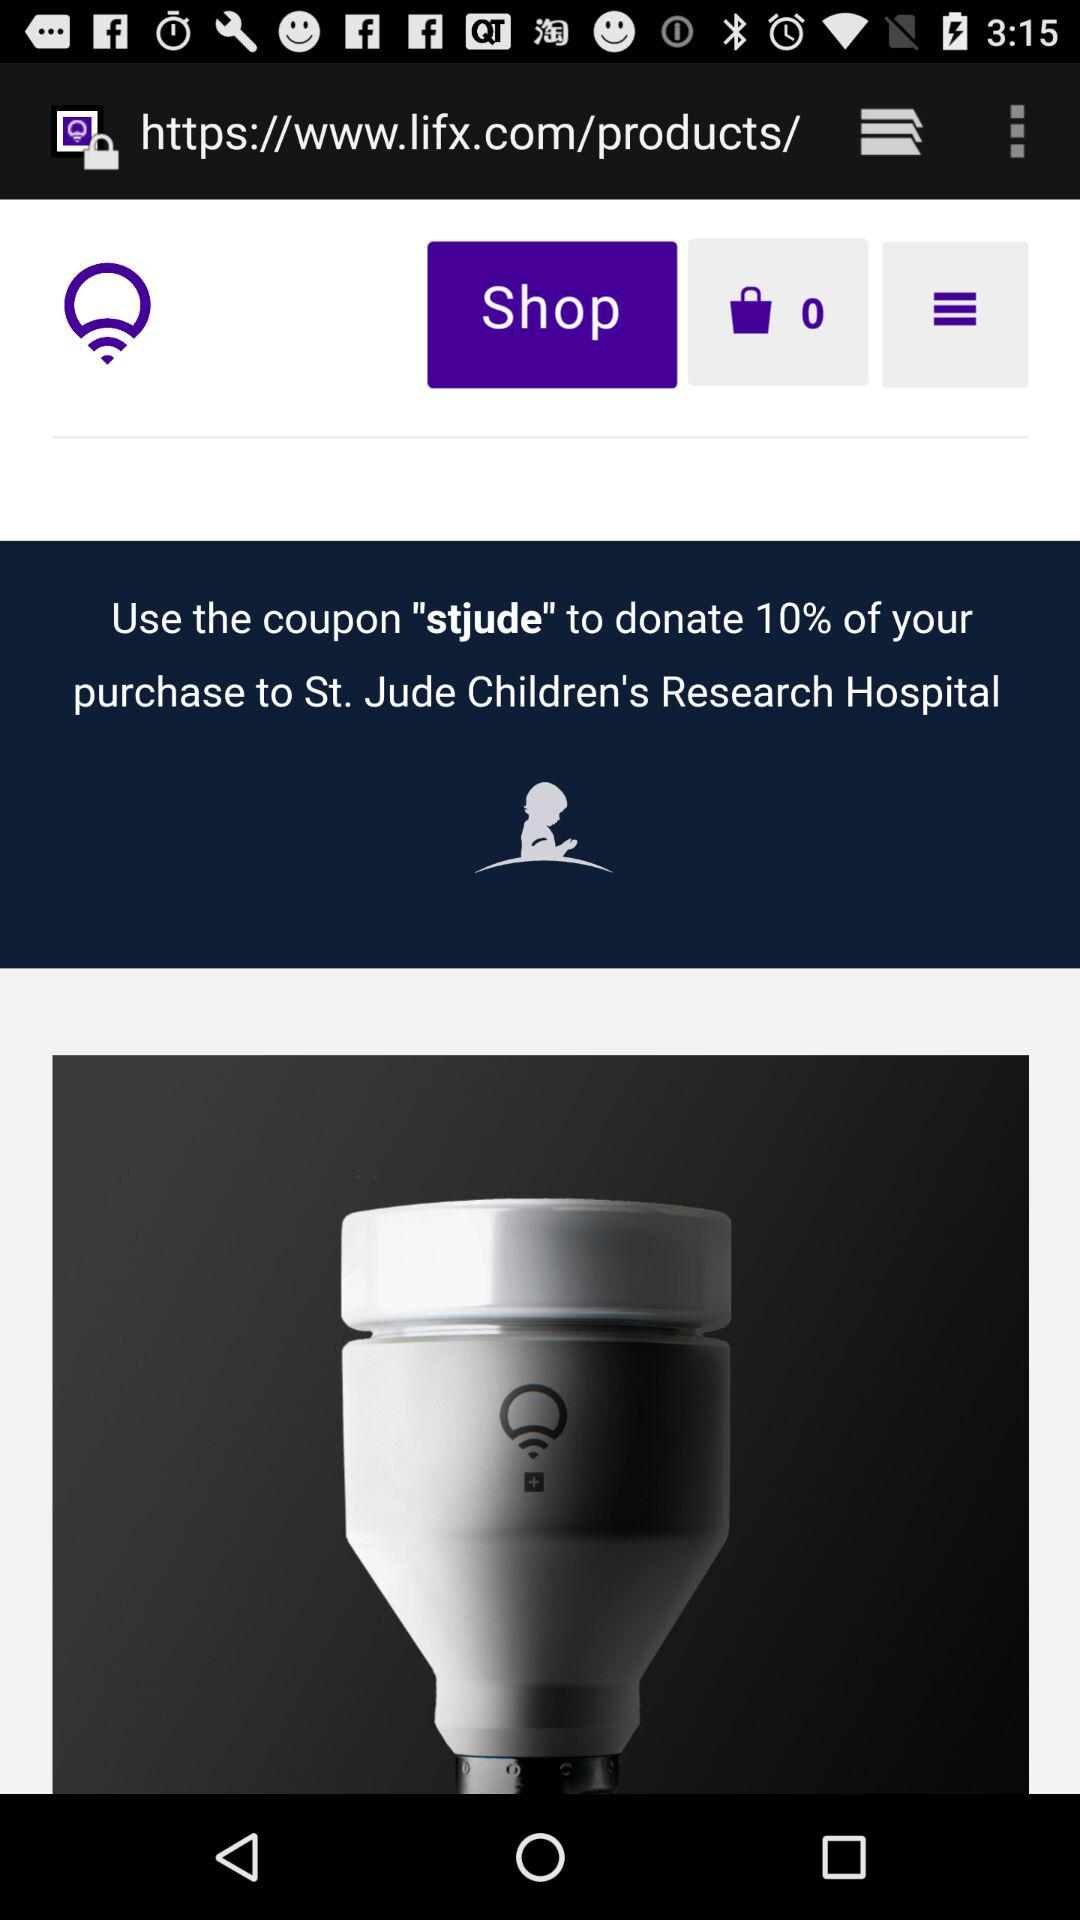What is the coupon code? The coupon code is "stjude". 